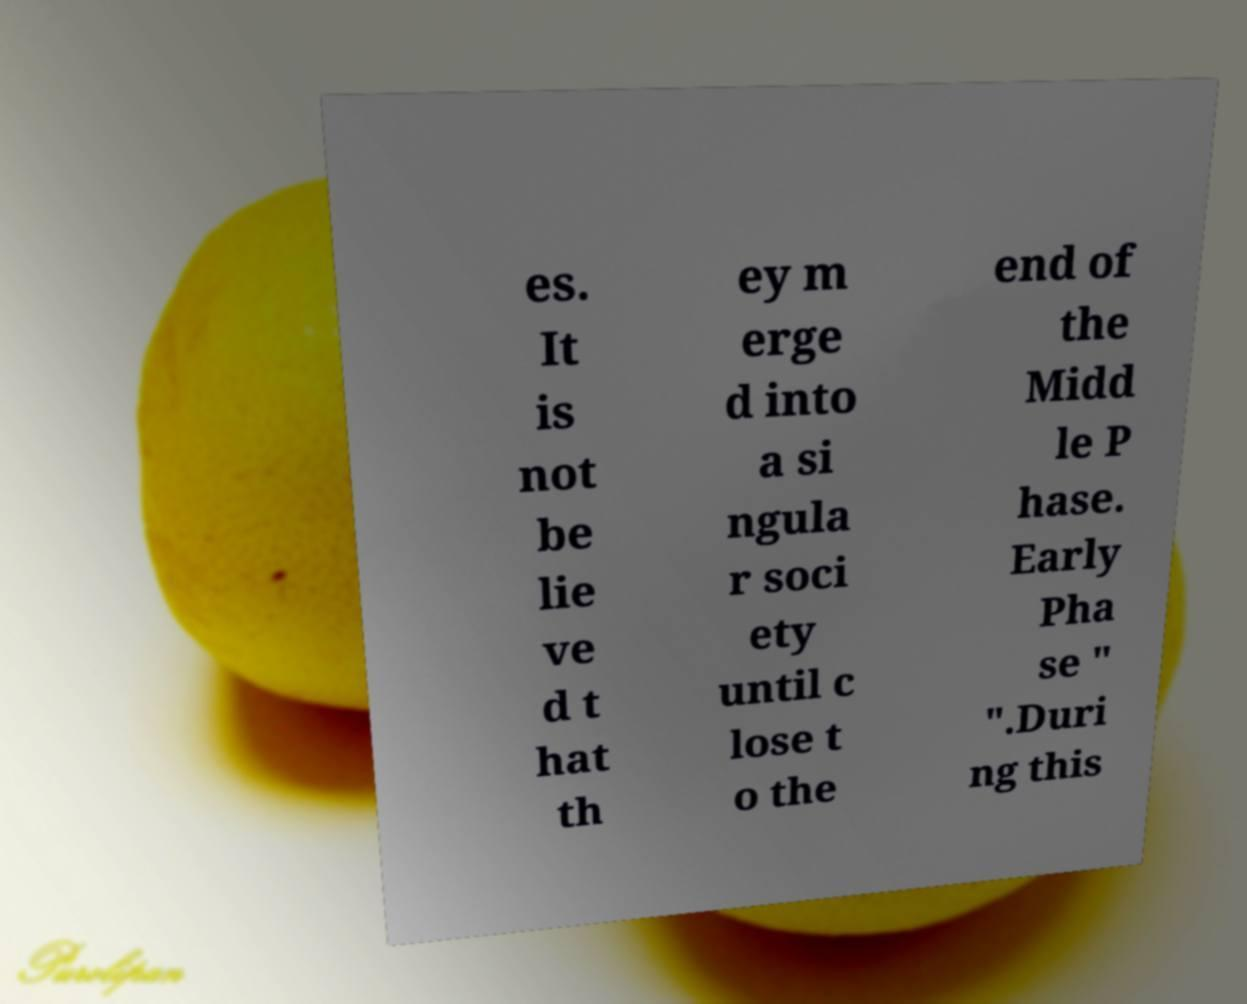Could you extract and type out the text from this image? es. It is not be lie ve d t hat th ey m erge d into a si ngula r soci ety until c lose t o the end of the Midd le P hase. Early Pha se " ".Duri ng this 